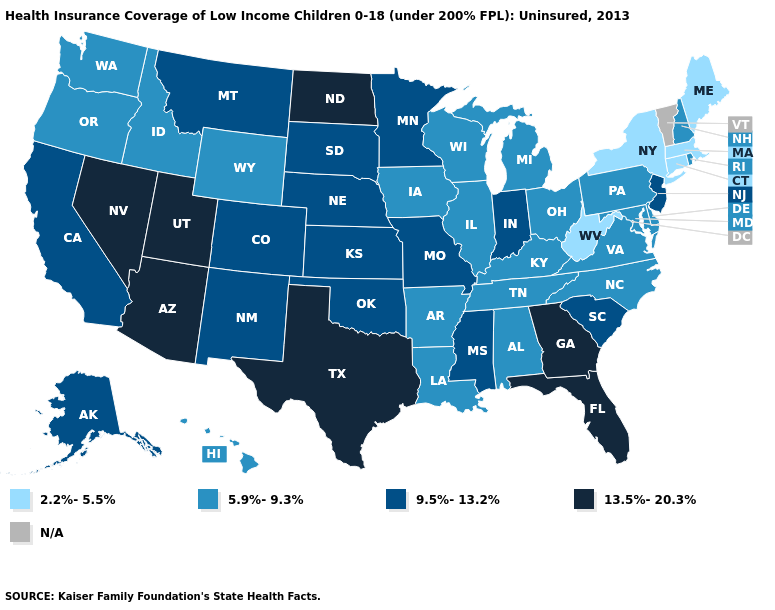Does the first symbol in the legend represent the smallest category?
Concise answer only. Yes. Among the states that border Nebraska , which have the highest value?
Quick response, please. Colorado, Kansas, Missouri, South Dakota. What is the highest value in the Northeast ?
Give a very brief answer. 9.5%-13.2%. Name the states that have a value in the range 2.2%-5.5%?
Be succinct. Connecticut, Maine, Massachusetts, New York, West Virginia. Which states have the highest value in the USA?
Concise answer only. Arizona, Florida, Georgia, Nevada, North Dakota, Texas, Utah. Does Texas have the highest value in the USA?
Write a very short answer. Yes. What is the value of Pennsylvania?
Write a very short answer. 5.9%-9.3%. What is the value of Wisconsin?
Keep it brief. 5.9%-9.3%. Name the states that have a value in the range 9.5%-13.2%?
Keep it brief. Alaska, California, Colorado, Indiana, Kansas, Minnesota, Mississippi, Missouri, Montana, Nebraska, New Jersey, New Mexico, Oklahoma, South Carolina, South Dakota. Name the states that have a value in the range 2.2%-5.5%?
Write a very short answer. Connecticut, Maine, Massachusetts, New York, West Virginia. What is the value of West Virginia?
Answer briefly. 2.2%-5.5%. Name the states that have a value in the range 13.5%-20.3%?
Quick response, please. Arizona, Florida, Georgia, Nevada, North Dakota, Texas, Utah. Which states hav the highest value in the South?
Write a very short answer. Florida, Georgia, Texas. 